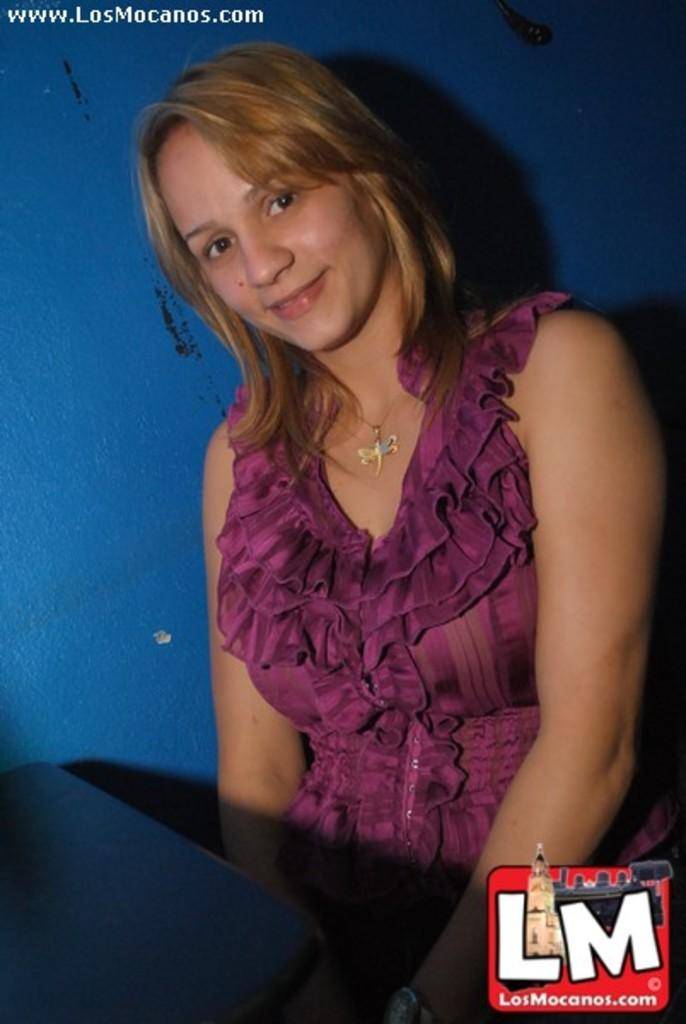Who is the main subject in the image? There is a lady in the center of the image. What else can be seen in the image besides the lady? There is text at the top side of the image. What is the purpose of the cushion in the image? There is no cushion present in the image. How does the lady express disgust in the image? The image does not show the lady expressing disgust; there is no indication of her emotions. 